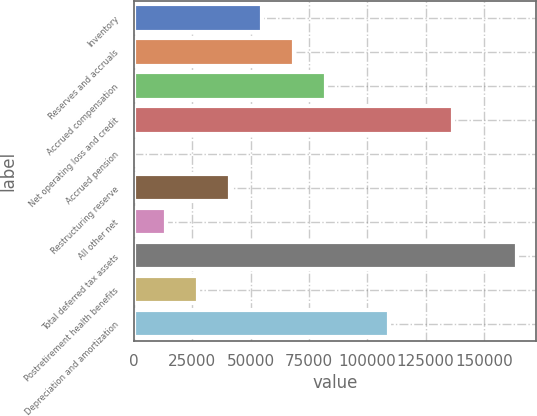Convert chart. <chart><loc_0><loc_0><loc_500><loc_500><bar_chart><fcel>Inventory<fcel>Reserves and accruals<fcel>Accrued compensation<fcel>Net operating loss and credit<fcel>Accrued pension<fcel>Restructuring reserve<fcel>All other net<fcel>Total deferred tax assets<fcel>Postretirement health benefits<fcel>Depreciation and amortization<nl><fcel>54791<fcel>68468<fcel>82145<fcel>136853<fcel>83<fcel>41114<fcel>13760<fcel>164207<fcel>27437<fcel>109499<nl></chart> 